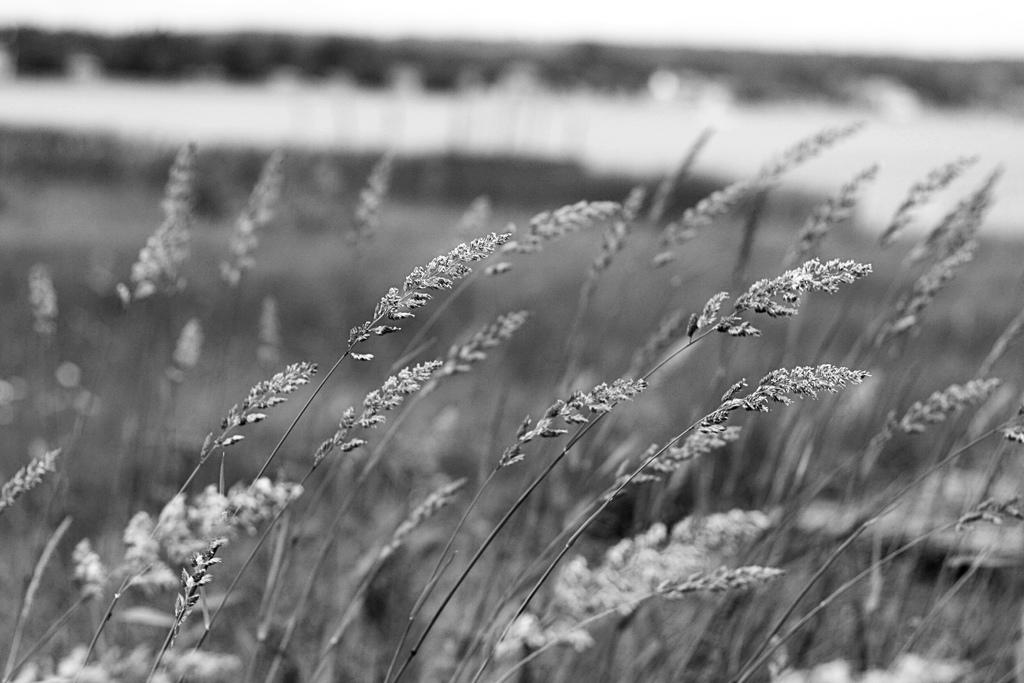What is the color scheme of the image? The image is black and white. What type of living organisms can be seen in the image? There are plants in the image. Can you describe the background of the image? The background of the image is blurred. What type of cloud can be seen in the image? There is no cloud present in the image, as it is black and white and does not depict any sky or weather elements. 